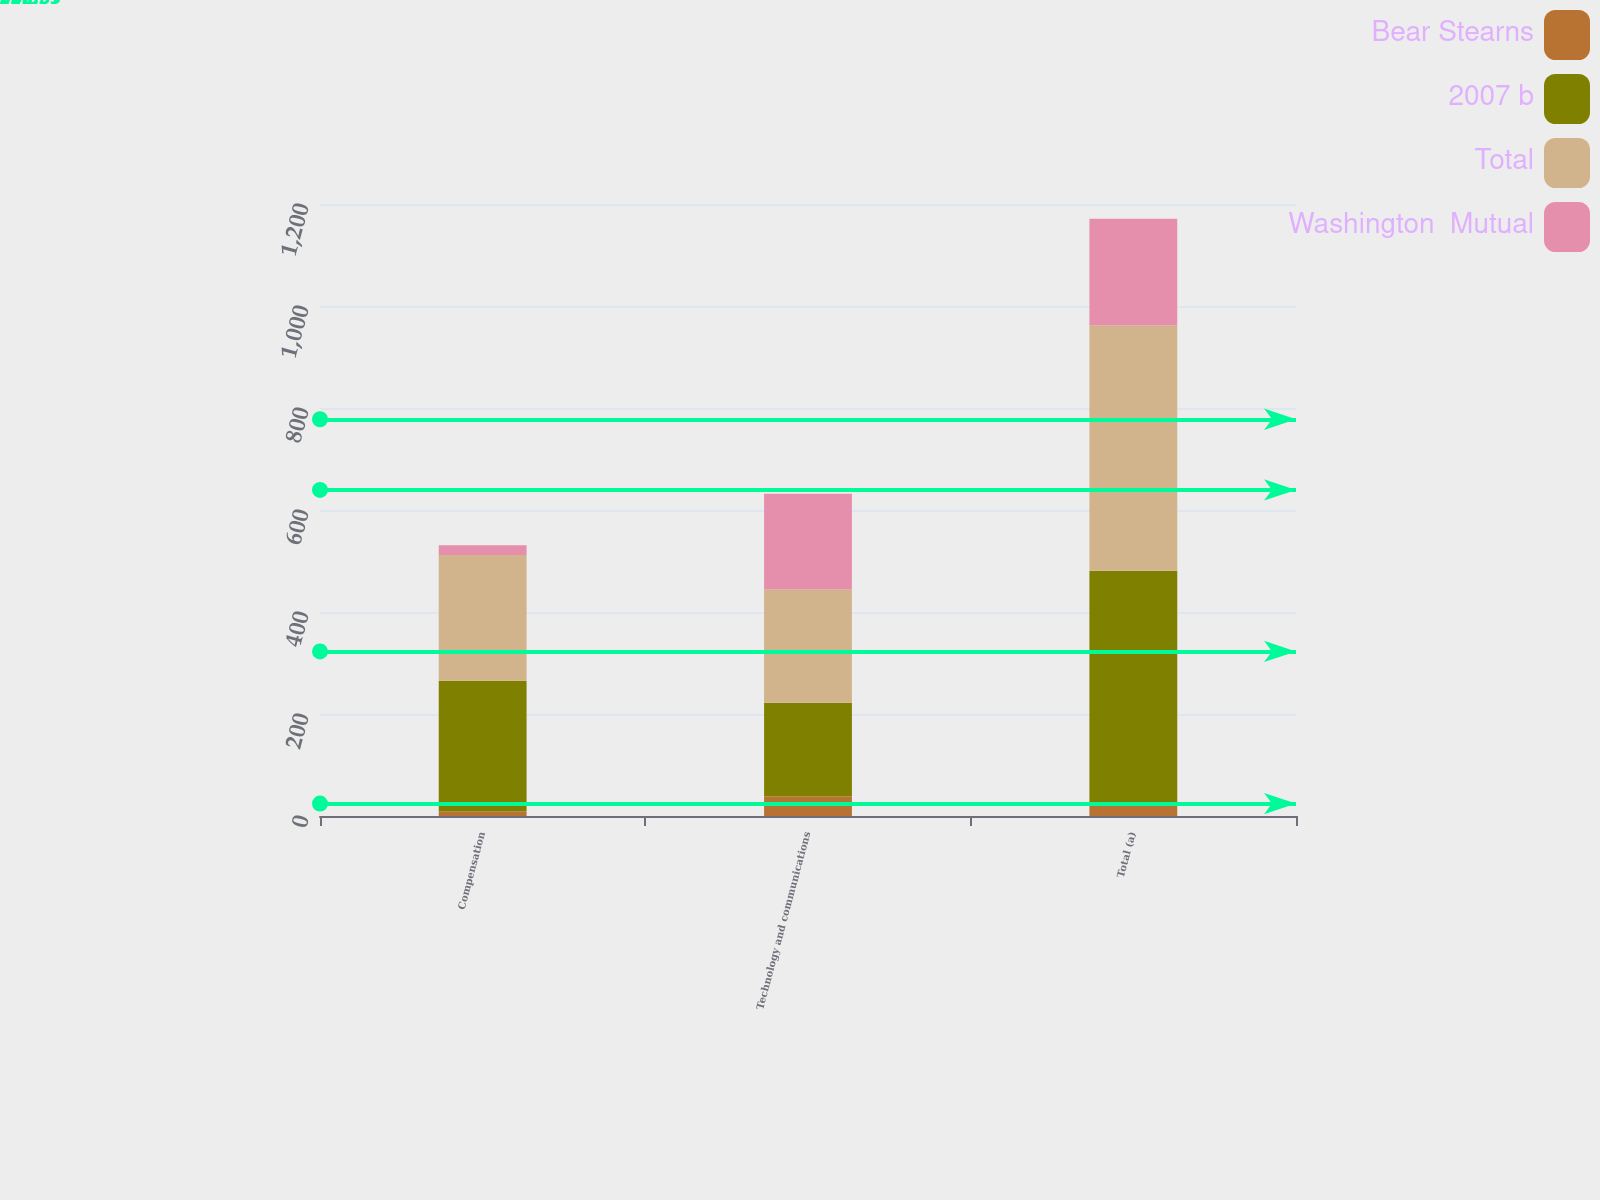Convert chart to OTSL. <chart><loc_0><loc_0><loc_500><loc_500><stacked_bar_chart><ecel><fcel>Compensation<fcel>Technology and communications<fcel>Total (a)<nl><fcel>Bear Stearns<fcel>9<fcel>38<fcel>26<nl><fcel>2007 b<fcel>256<fcel>184<fcel>455<nl><fcel>Total<fcel>247<fcel>222<fcel>481<nl><fcel>Washington  Mutual<fcel>19<fcel>188<fcel>209<nl></chart> 